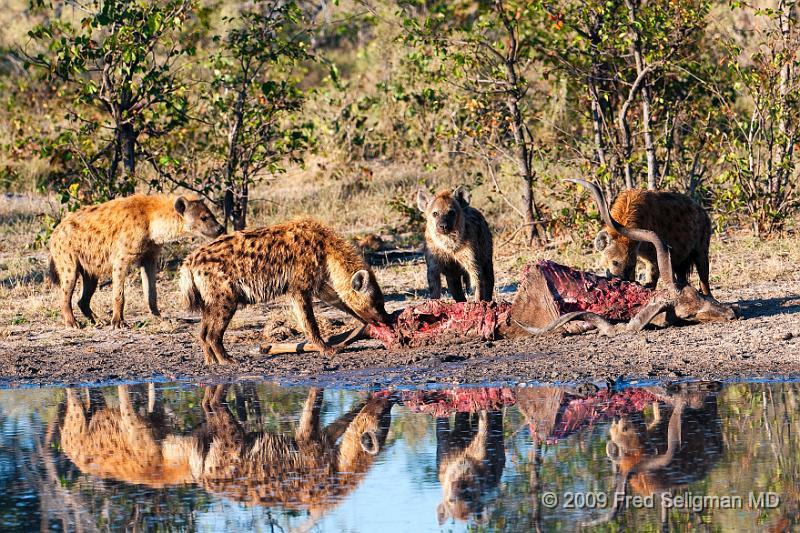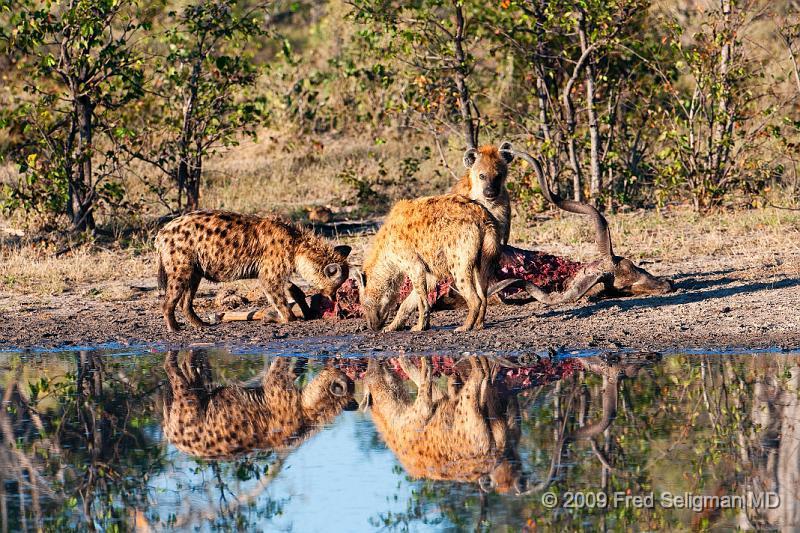The first image is the image on the left, the second image is the image on the right. For the images shown, is this caption "One of the images features only one hyena." true? Answer yes or no. No. The first image is the image on the left, the second image is the image on the right. Considering the images on both sides, is "An image shows a hyena near the carcass of a giraffe with its spotted hooved legs visible." valid? Answer yes or no. No. 